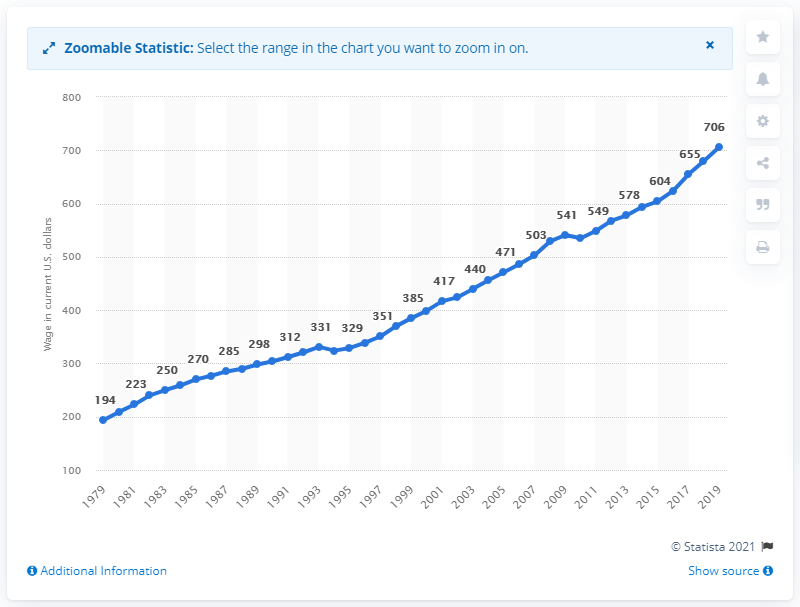Highlight a few significant elements in this photo. The median weekly earnings of a Latino full-time employee in 2019 was $706. The median weekly earnings of a Latino full-time employee in the United States was $194 in 1979. 